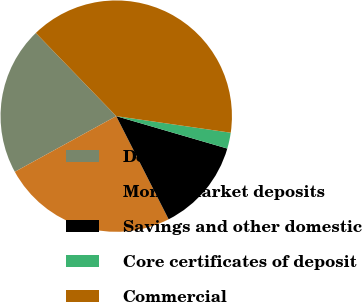Convert chart to OTSL. <chart><loc_0><loc_0><loc_500><loc_500><pie_chart><fcel>Demand<fcel>Money market deposits<fcel>Savings and other domestic<fcel>Core certificates of deposit<fcel>Commercial<nl><fcel>20.76%<fcel>24.49%<fcel>13.0%<fcel>2.23%<fcel>39.52%<nl></chart> 